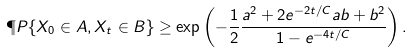<formula> <loc_0><loc_0><loc_500><loc_500>\P P \{ X _ { 0 } \in A , X _ { t } \in B \} \geq \exp \left ( - \frac { 1 } { 2 } \frac { a ^ { 2 } + 2 e ^ { - 2 t / C } a b + b ^ { 2 } } { 1 - e ^ { - 4 t / C } } \right ) .</formula> 